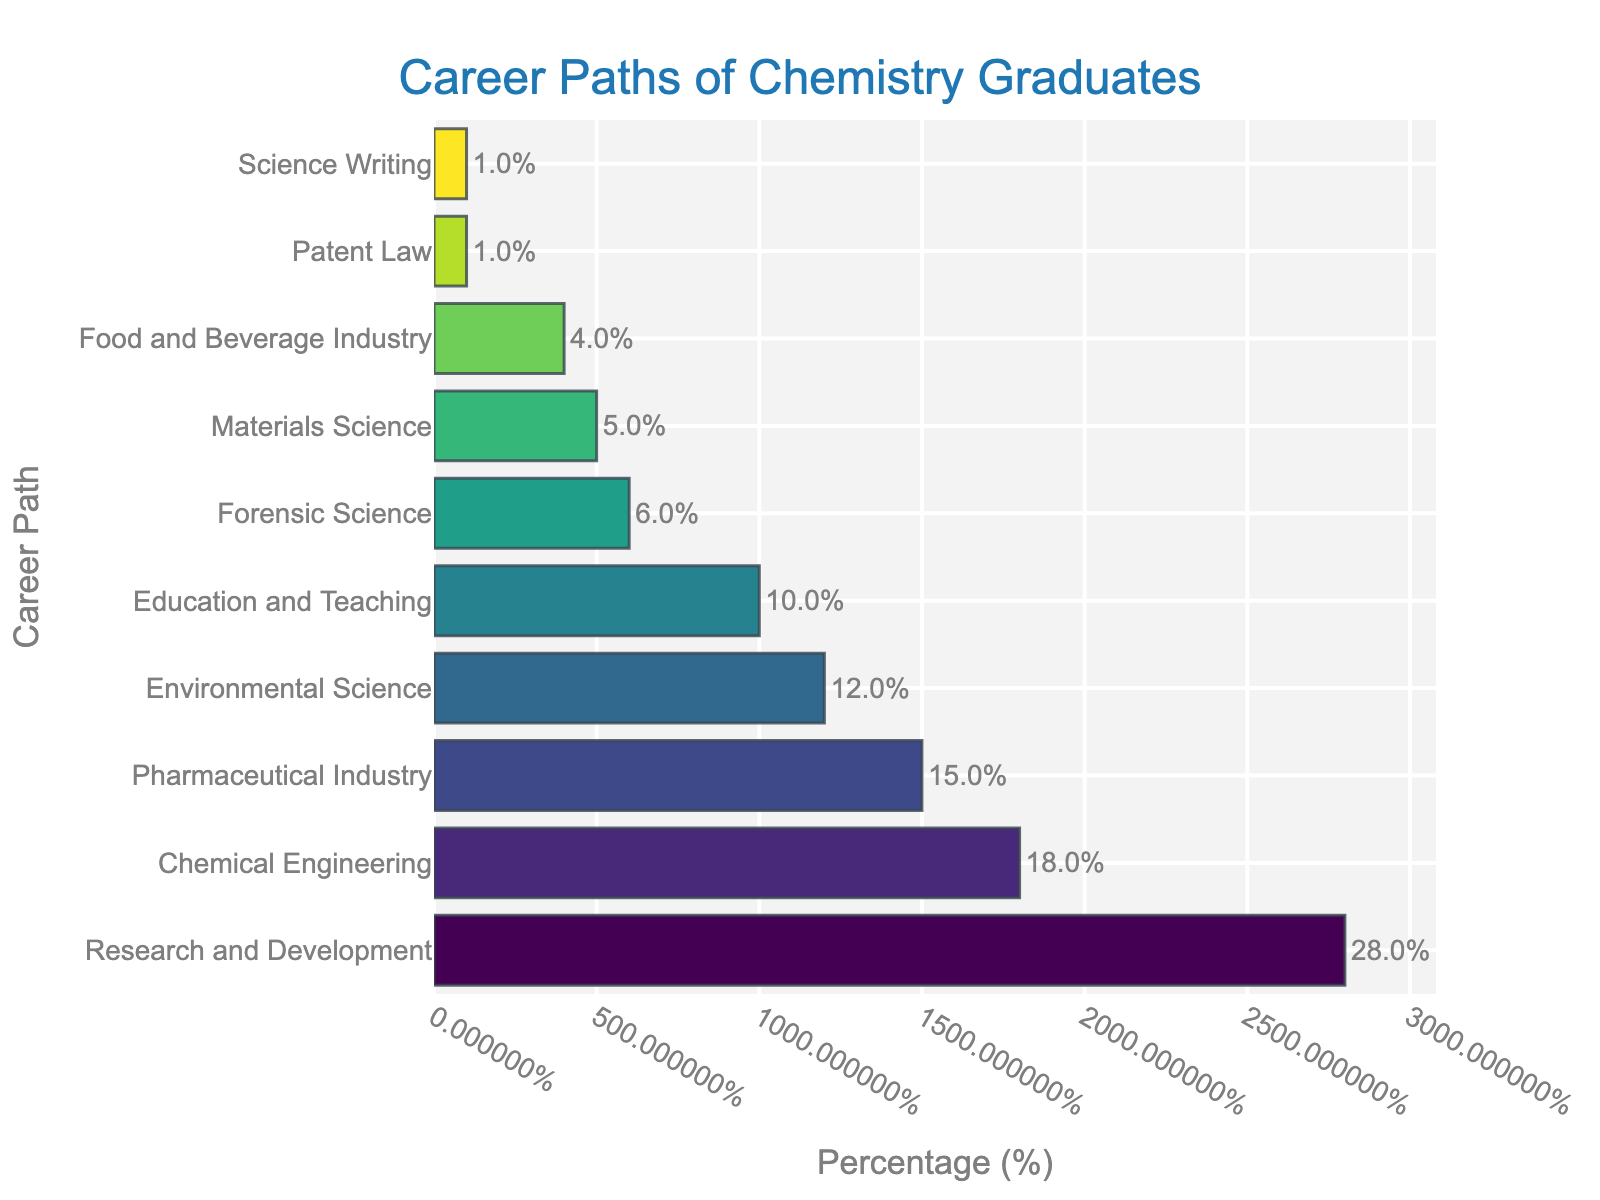what is the most common career path for chemistry graduates? The most common career path can be identified as the bar with the highest percentage. From the figure, the 'Research and Development' bar is the highest, indicating it is the most common career path.
Answer: Research and Development What is the percentage of chemistry graduates who go into the Pharmaceutical Industry? Look for the bar labeled 'Pharmaceutical Industry' and check its length. The length corresponds to 15%.
Answer: 15% Which career paths have the same percentage of chemistry graduates pursuing them? Identify bars of equal length. 'Patent Law' and 'Science Writing' both have bars representing 1%.
Answer: Patent Law and Science Writing What are the combined percentages of graduates in Research and Development and Chemical Engineering? Add the percentages of 'Research and Development' and 'Chemical Engineering': 28% + 18% = 46%.
Answer: 46% Which career path has the lowest percentage of chemistry graduates? Identify the shortest bar. The 'Patent Law' and 'Science Writing' bars are both the shortest at 1%.
Answer: Patent Law and Science Writing How many career paths have at least 10% of chemistry graduates pursuing them? Count the bars that are 10% or higher. There are four: 'Research and Development', 'Chemical Engineering', 'Pharmaceutical Industry', and 'Environmental Science'.
Answer: 4 What is the difference in percentage between Environmental Science and Education and Teaching? Subtract the percentage of 'Education and Teaching' from 'Environmental Science': 12% - 10% = 2%.
Answer: 2% Which career path has a slightly higher percentage of graduates than Forensic Science? Identify the career path with a bar just longer than the 'Forensic Science' bar. 'Education and Teaching' is slightly higher at 10% compared to Forensic Science at 6%.
Answer: Education and Teaching What is the sum of percentages for career paths with less than 10% graduates pursuing them? Sum the percentages of career paths below 10%: 6% (Forensic Science) + 5% (Materials Science) + 4% (Food and Beverage Industry) + 1% (Patent Law) + 1% (Science Writing) = 17%.
Answer: 17% Visually, which bar stands out the most and why? The 'Research and Development' bar stands out the most because it is the tallest and has the most prominent color.
Answer: Research and Development 